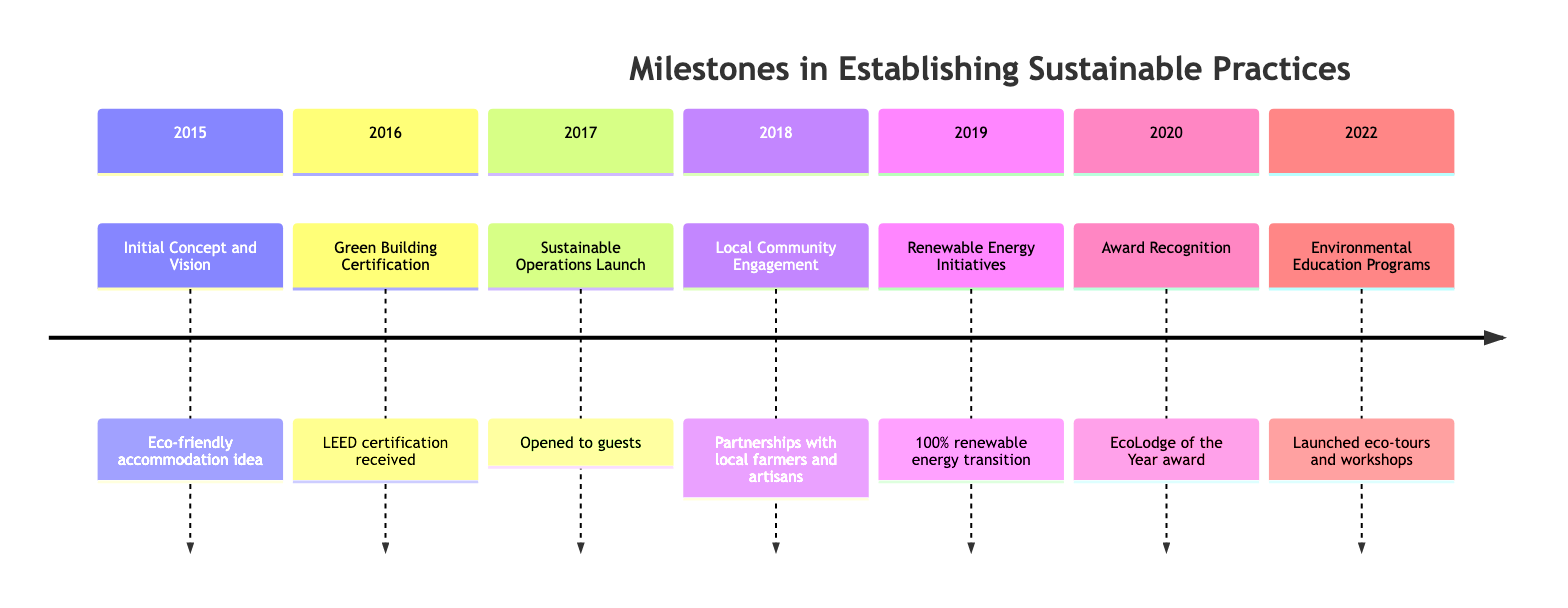What was the first milestone in establishing sustainable practices? The first milestone listed in the timeline is from 2015, titled "Initial Concept and Vision." This milestone sets the foundation for the eco-friendly accommodation idea.
Answer: Initial Concept and Vision How many milestones are there in total? By counting each individual milestone from 2015 to 2022, we can determine that there are seven milestones presented in the timeline.
Answer: 7 What year did the accommodation receive Green Building Certification? The timeline indicates that the Green Building Certification milestone occurred in 2016, which marks the year the accommodation's construction was completed using sustainable materials.
Answer: 2016 What is the milestone for the year 2019? According to the timeline, the milestone for the year 2019 is "Renewable Energy Initiatives," which highlights the transition to 100% renewable energy sources.
Answer: Renewable Energy Initiatives What significant award was received in 2020? The milestone in the year 2020 refers to the award "EcoLodge of the Year," which was given for excellence in sustainable hospitality.
Answer: EcoLodge of the Year Which year marked the launch of Environmental Education Programs? The timeline shows that Environmental Education Programs were launched in 2022, reflecting a focus on promoting environmental conservation among guests.
Answer: 2022 What was the last milestone before the award recognition in 2020? The last milestone before the award recognition in 2020, found in the timeline, is "Renewable Energy Initiatives," which occurred in 2019, emphasizing the transition to renewable energy.
Answer: Renewable Energy Initiatives Which milestone involved training staff on eco-friendly practices? The timeline indicates that the "Sustainable Operations Launch" milestone, occurring in 2017, involved training staff on eco-friendly practices, marking the accommodation's opening to guests.
Answer: Sustainable Operations Launch What action item was associated with the Local Community Engagement milestone? The timeline details that one of the action items under the "Local Community Engagement" milestone, which was in 2018, was organizing local produce markets onsite, fostering partnerships with local farmers and artisans.
Answer: Organizing local produce markets onsite 